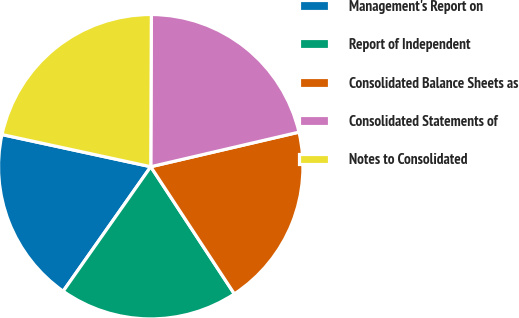Convert chart to OTSL. <chart><loc_0><loc_0><loc_500><loc_500><pie_chart><fcel>Management's Report on<fcel>Report of Independent<fcel>Consolidated Balance Sheets as<fcel>Consolidated Statements of<fcel>Notes to Consolidated<nl><fcel>18.63%<fcel>19.01%<fcel>19.39%<fcel>21.29%<fcel>21.67%<nl></chart> 